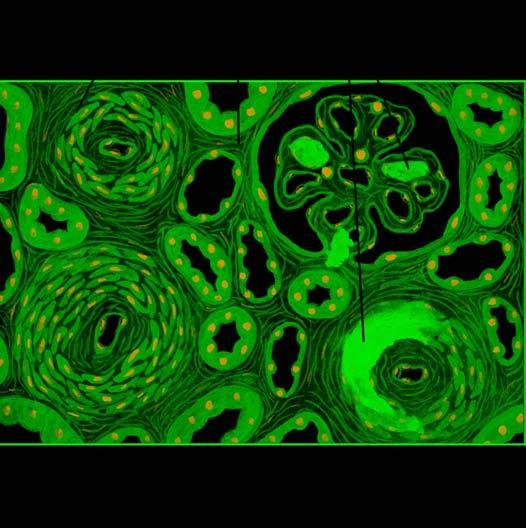re the bronchioles as well as the adjacent alveoli tubular loss, fine interstitial fibrosis and foci of infarction necrosis?
Answer the question using a single word or phrase. No 